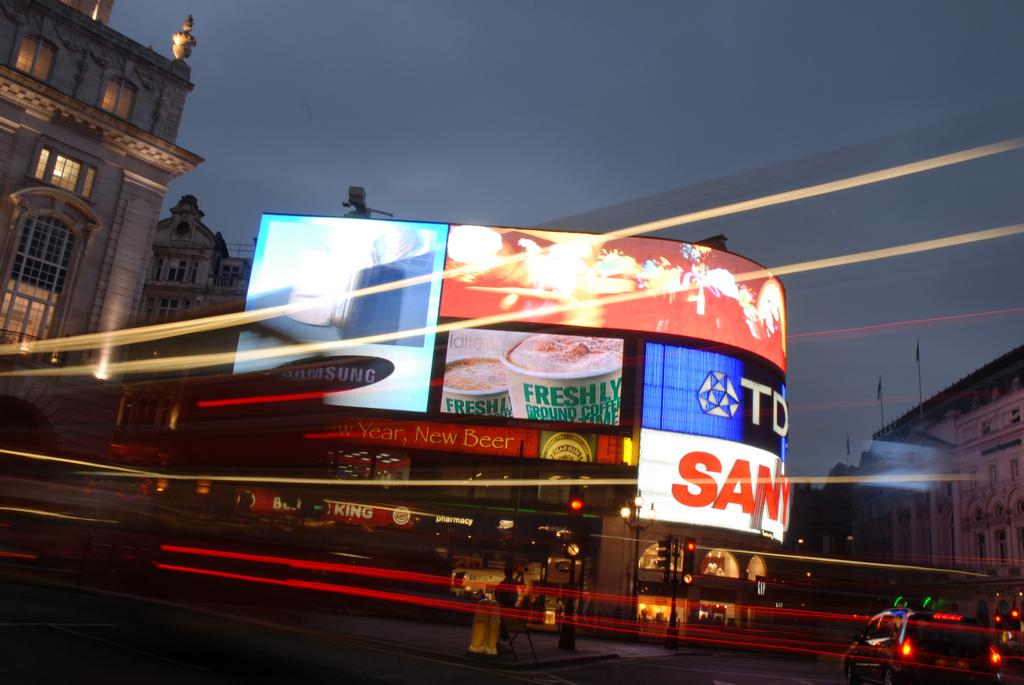Provide a one-sentence caption for the provided image. Neon lit billboard signs are displayed on a side of a street at night and the letters TD can be seen. 